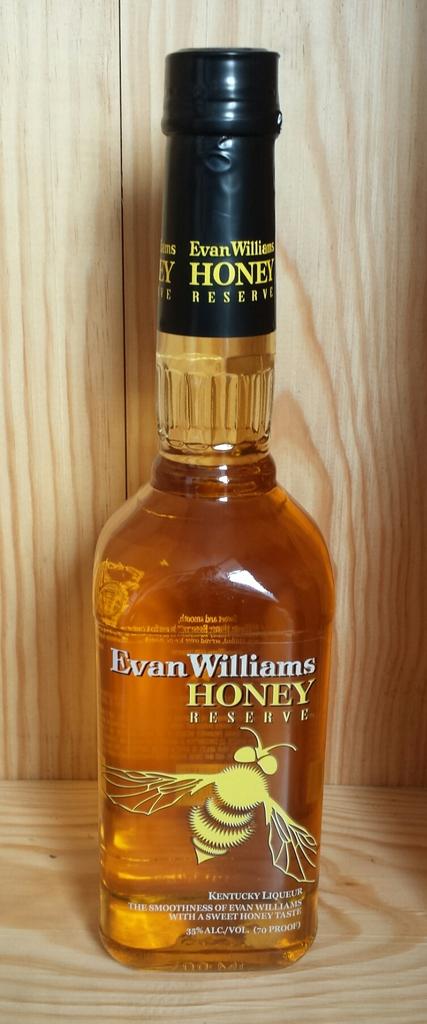What company produced this honey reserve?
Your answer should be very brief. Evan williams. What is inside this bottle?
Offer a very short reply. Honey reserve. 